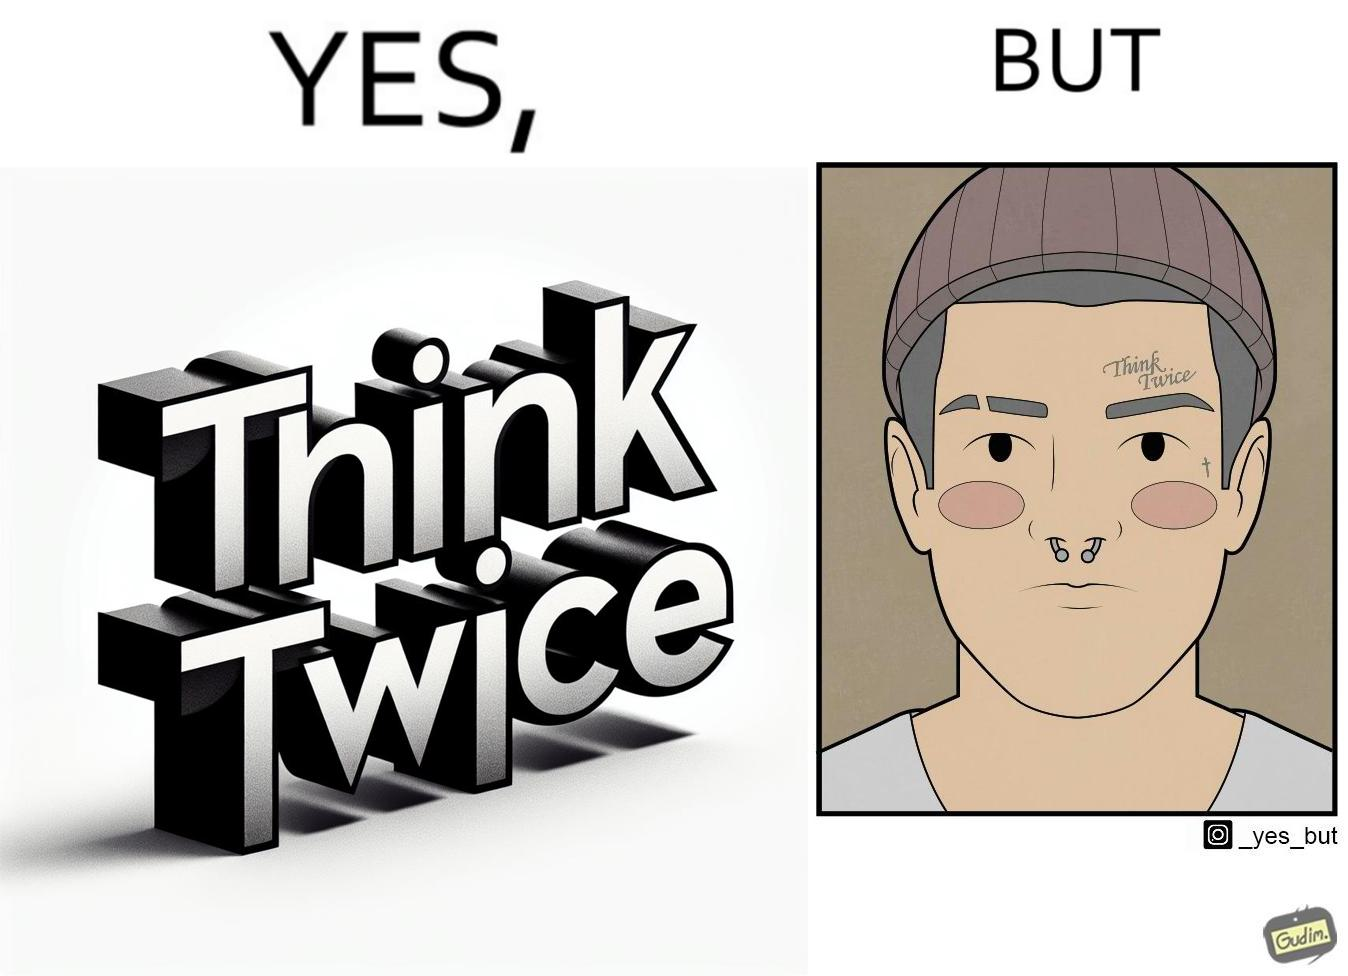Would you classify this image as satirical? Yes, this image is satirical. 